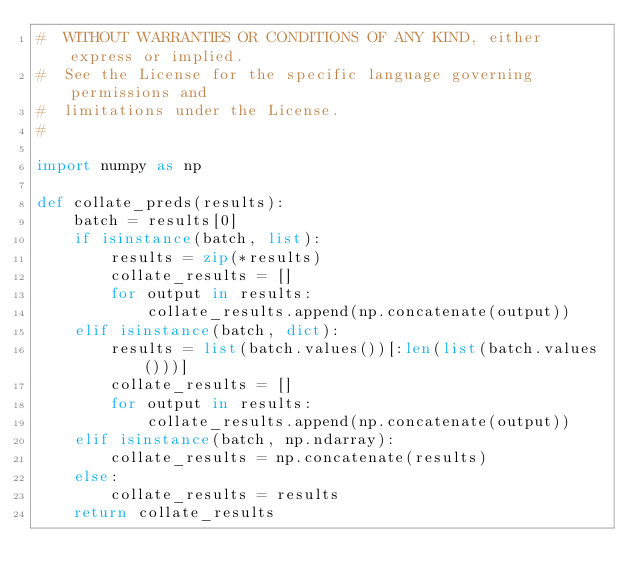Convert code to text. <code><loc_0><loc_0><loc_500><loc_500><_Python_>#  WITHOUT WARRANTIES OR CONDITIONS OF ANY KIND, either express or implied.
#  See the License for the specific language governing permissions and
#  limitations under the License.
#

import numpy as np

def collate_preds(results):
    batch = results[0]
    if isinstance(batch, list):
        results = zip(*results)
        collate_results = []
        for output in results:
            collate_results.append(np.concatenate(output))
    elif isinstance(batch, dict):
        results = list(batch.values())[:len(list(batch.values()))]
        collate_results = []
        for output in results:
            collate_results.append(np.concatenate(output))
    elif isinstance(batch, np.ndarray):
        collate_results = np.concatenate(results)
    else:
        collate_results = results
    return collate_results
</code> 